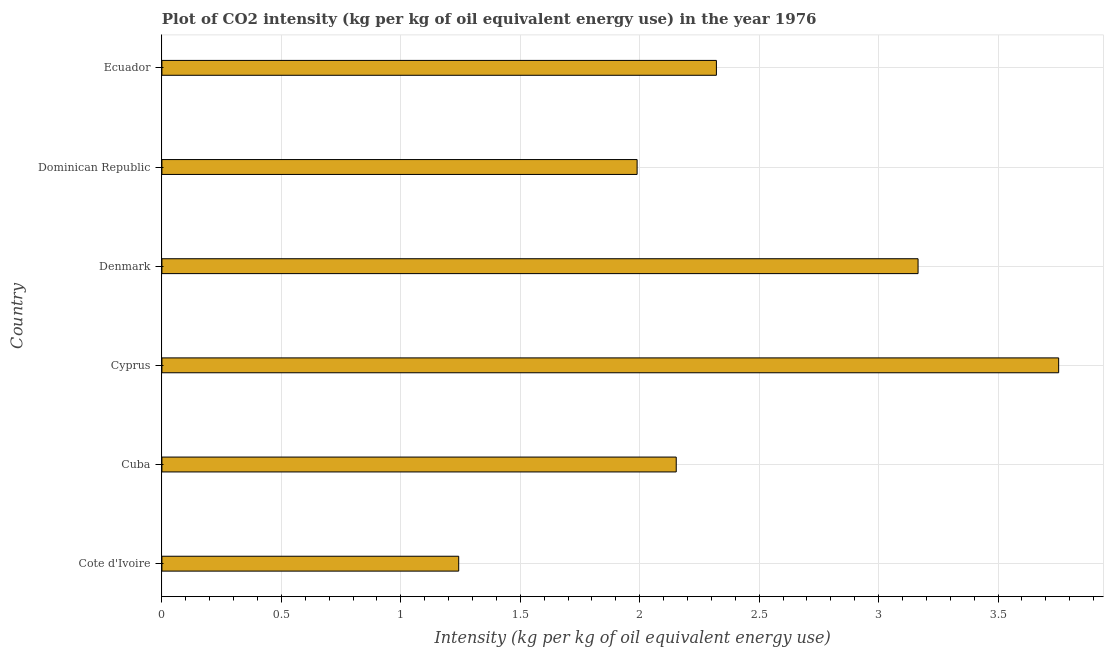Does the graph contain any zero values?
Ensure brevity in your answer.  No. What is the title of the graph?
Give a very brief answer. Plot of CO2 intensity (kg per kg of oil equivalent energy use) in the year 1976. What is the label or title of the X-axis?
Give a very brief answer. Intensity (kg per kg of oil equivalent energy use). What is the co2 intensity in Cyprus?
Your answer should be compact. 3.75. Across all countries, what is the maximum co2 intensity?
Keep it short and to the point. 3.75. Across all countries, what is the minimum co2 intensity?
Ensure brevity in your answer.  1.24. In which country was the co2 intensity maximum?
Your answer should be compact. Cyprus. In which country was the co2 intensity minimum?
Make the answer very short. Cote d'Ivoire. What is the sum of the co2 intensity?
Provide a short and direct response. 14.62. What is the difference between the co2 intensity in Cote d'Ivoire and Dominican Republic?
Provide a short and direct response. -0.75. What is the average co2 intensity per country?
Your response must be concise. 2.44. What is the median co2 intensity?
Your answer should be compact. 2.24. In how many countries, is the co2 intensity greater than 1.6 kg?
Keep it short and to the point. 5. What is the ratio of the co2 intensity in Cote d'Ivoire to that in Denmark?
Your response must be concise. 0.39. What is the difference between the highest and the second highest co2 intensity?
Ensure brevity in your answer.  0.59. Is the sum of the co2 intensity in Cuba and Ecuador greater than the maximum co2 intensity across all countries?
Keep it short and to the point. Yes. What is the difference between the highest and the lowest co2 intensity?
Provide a short and direct response. 2.51. How many bars are there?
Make the answer very short. 6. What is the difference between two consecutive major ticks on the X-axis?
Ensure brevity in your answer.  0.5. Are the values on the major ticks of X-axis written in scientific E-notation?
Ensure brevity in your answer.  No. What is the Intensity (kg per kg of oil equivalent energy use) in Cote d'Ivoire?
Provide a short and direct response. 1.24. What is the Intensity (kg per kg of oil equivalent energy use) in Cuba?
Provide a short and direct response. 2.15. What is the Intensity (kg per kg of oil equivalent energy use) of Cyprus?
Provide a succinct answer. 3.75. What is the Intensity (kg per kg of oil equivalent energy use) of Denmark?
Provide a short and direct response. 3.17. What is the Intensity (kg per kg of oil equivalent energy use) of Dominican Republic?
Offer a very short reply. 1.99. What is the Intensity (kg per kg of oil equivalent energy use) of Ecuador?
Your answer should be compact. 2.32. What is the difference between the Intensity (kg per kg of oil equivalent energy use) in Cote d'Ivoire and Cuba?
Your response must be concise. -0.91. What is the difference between the Intensity (kg per kg of oil equivalent energy use) in Cote d'Ivoire and Cyprus?
Your answer should be compact. -2.51. What is the difference between the Intensity (kg per kg of oil equivalent energy use) in Cote d'Ivoire and Denmark?
Provide a short and direct response. -1.92. What is the difference between the Intensity (kg per kg of oil equivalent energy use) in Cote d'Ivoire and Dominican Republic?
Your answer should be very brief. -0.75. What is the difference between the Intensity (kg per kg of oil equivalent energy use) in Cote d'Ivoire and Ecuador?
Your answer should be very brief. -1.08. What is the difference between the Intensity (kg per kg of oil equivalent energy use) in Cuba and Cyprus?
Offer a terse response. -1.6. What is the difference between the Intensity (kg per kg of oil equivalent energy use) in Cuba and Denmark?
Give a very brief answer. -1.01. What is the difference between the Intensity (kg per kg of oil equivalent energy use) in Cuba and Dominican Republic?
Keep it short and to the point. 0.16. What is the difference between the Intensity (kg per kg of oil equivalent energy use) in Cuba and Ecuador?
Keep it short and to the point. -0.17. What is the difference between the Intensity (kg per kg of oil equivalent energy use) in Cyprus and Denmark?
Your answer should be compact. 0.59. What is the difference between the Intensity (kg per kg of oil equivalent energy use) in Cyprus and Dominican Republic?
Offer a terse response. 1.76. What is the difference between the Intensity (kg per kg of oil equivalent energy use) in Cyprus and Ecuador?
Keep it short and to the point. 1.43. What is the difference between the Intensity (kg per kg of oil equivalent energy use) in Denmark and Dominican Republic?
Your answer should be compact. 1.18. What is the difference between the Intensity (kg per kg of oil equivalent energy use) in Denmark and Ecuador?
Make the answer very short. 0.84. What is the difference between the Intensity (kg per kg of oil equivalent energy use) in Dominican Republic and Ecuador?
Your answer should be very brief. -0.33. What is the ratio of the Intensity (kg per kg of oil equivalent energy use) in Cote d'Ivoire to that in Cuba?
Provide a succinct answer. 0.58. What is the ratio of the Intensity (kg per kg of oil equivalent energy use) in Cote d'Ivoire to that in Cyprus?
Provide a succinct answer. 0.33. What is the ratio of the Intensity (kg per kg of oil equivalent energy use) in Cote d'Ivoire to that in Denmark?
Offer a terse response. 0.39. What is the ratio of the Intensity (kg per kg of oil equivalent energy use) in Cote d'Ivoire to that in Ecuador?
Offer a terse response. 0.54. What is the ratio of the Intensity (kg per kg of oil equivalent energy use) in Cuba to that in Cyprus?
Provide a short and direct response. 0.57. What is the ratio of the Intensity (kg per kg of oil equivalent energy use) in Cuba to that in Denmark?
Offer a terse response. 0.68. What is the ratio of the Intensity (kg per kg of oil equivalent energy use) in Cuba to that in Dominican Republic?
Keep it short and to the point. 1.08. What is the ratio of the Intensity (kg per kg of oil equivalent energy use) in Cuba to that in Ecuador?
Offer a terse response. 0.93. What is the ratio of the Intensity (kg per kg of oil equivalent energy use) in Cyprus to that in Denmark?
Give a very brief answer. 1.19. What is the ratio of the Intensity (kg per kg of oil equivalent energy use) in Cyprus to that in Dominican Republic?
Your answer should be very brief. 1.89. What is the ratio of the Intensity (kg per kg of oil equivalent energy use) in Cyprus to that in Ecuador?
Keep it short and to the point. 1.62. What is the ratio of the Intensity (kg per kg of oil equivalent energy use) in Denmark to that in Dominican Republic?
Your answer should be very brief. 1.59. What is the ratio of the Intensity (kg per kg of oil equivalent energy use) in Denmark to that in Ecuador?
Offer a terse response. 1.36. What is the ratio of the Intensity (kg per kg of oil equivalent energy use) in Dominican Republic to that in Ecuador?
Provide a succinct answer. 0.86. 